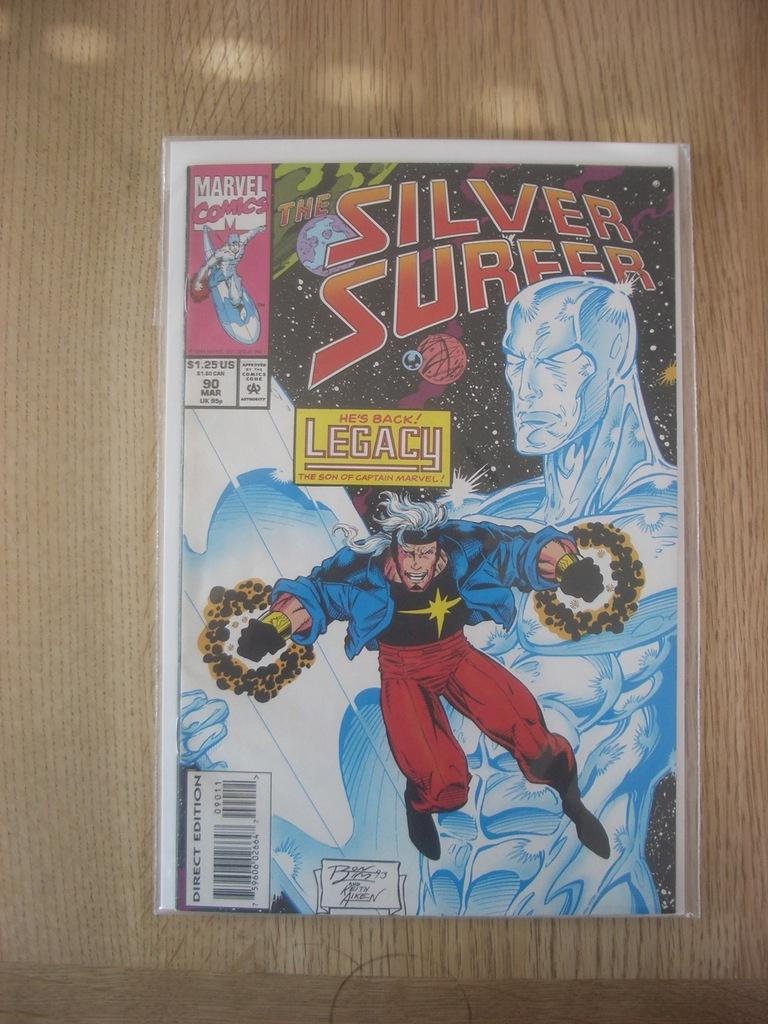<image>
Describe the image concisely. A marvel comic has a super hero on the front and is marked for a price of a dollar twenty five. 